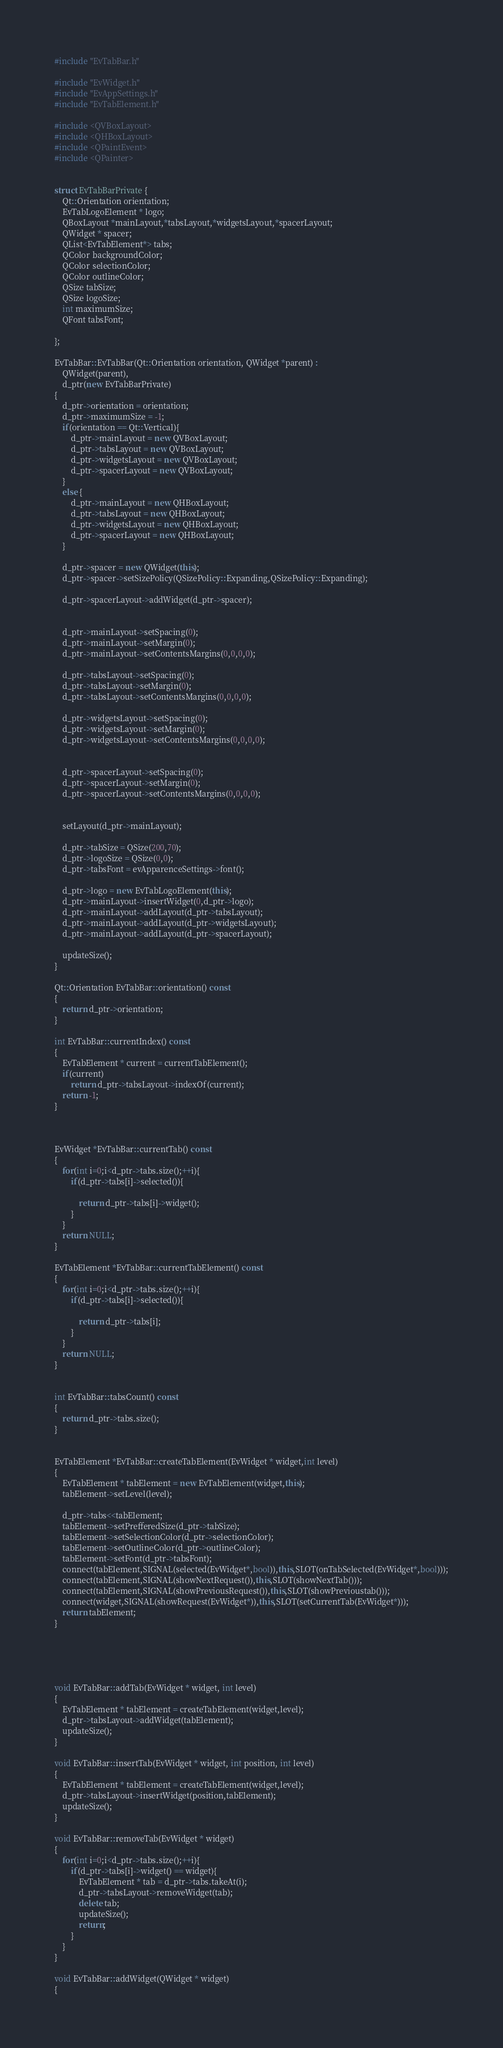Convert code to text. <code><loc_0><loc_0><loc_500><loc_500><_C++_>#include "EvTabBar.h"

#include "EvWidget.h"
#include "EvAppSettings.h"
#include "EvTabElement.h"

#include <QVBoxLayout>
#include <QHBoxLayout>
#include <QPaintEvent>
#include <QPainter>


struct EvTabBarPrivate {
    Qt::Orientation orientation;
    EvTabLogoElement * logo;
    QBoxLayout *mainLayout,*tabsLayout,*widgetsLayout,*spacerLayout;
    QWidget * spacer;
    QList<EvTabElement*> tabs;
    QColor backgroundColor;
    QColor selectionColor;
    QColor outlineColor;
    QSize tabSize;
    QSize logoSize;
    int maximumSize;
    QFont tabsFont;

};

EvTabBar::EvTabBar(Qt::Orientation orientation, QWidget *parent) :
    QWidget(parent),
    d_ptr(new EvTabBarPrivate)
{
    d_ptr->orientation = orientation;
    d_ptr->maximumSize = -1;
    if(orientation == Qt::Vertical){
        d_ptr->mainLayout = new QVBoxLayout;
        d_ptr->tabsLayout = new QVBoxLayout;
        d_ptr->widgetsLayout = new QVBoxLayout;
        d_ptr->spacerLayout = new QVBoxLayout;
    }
    else {
        d_ptr->mainLayout = new QHBoxLayout;
        d_ptr->tabsLayout = new QHBoxLayout;
        d_ptr->widgetsLayout = new QHBoxLayout;
        d_ptr->spacerLayout = new QHBoxLayout;
    }

    d_ptr->spacer = new QWidget(this);
    d_ptr->spacer->setSizePolicy(QSizePolicy::Expanding,QSizePolicy::Expanding);

    d_ptr->spacerLayout->addWidget(d_ptr->spacer);


    d_ptr->mainLayout->setSpacing(0);
    d_ptr->mainLayout->setMargin(0);
    d_ptr->mainLayout->setContentsMargins(0,0,0,0);

    d_ptr->tabsLayout->setSpacing(0);
    d_ptr->tabsLayout->setMargin(0);
    d_ptr->tabsLayout->setContentsMargins(0,0,0,0);

    d_ptr->widgetsLayout->setSpacing(0);
    d_ptr->widgetsLayout->setMargin(0);
    d_ptr->widgetsLayout->setContentsMargins(0,0,0,0);


    d_ptr->spacerLayout->setSpacing(0);
    d_ptr->spacerLayout->setMargin(0);
    d_ptr->spacerLayout->setContentsMargins(0,0,0,0);


    setLayout(d_ptr->mainLayout);

    d_ptr->tabSize = QSize(200,70);
    d_ptr->logoSize = QSize(0,0);
    d_ptr->tabsFont = evApparenceSettings->font();

    d_ptr->logo = new EvTabLogoElement(this);
    d_ptr->mainLayout->insertWidget(0,d_ptr->logo);
    d_ptr->mainLayout->addLayout(d_ptr->tabsLayout);
    d_ptr->mainLayout->addLayout(d_ptr->widgetsLayout);
    d_ptr->mainLayout->addLayout(d_ptr->spacerLayout);

    updateSize();
}

Qt::Orientation EvTabBar::orientation() const
{
    return d_ptr->orientation;
}

int EvTabBar::currentIndex() const
{
    EvTabElement * current = currentTabElement();
    if(current)
        return d_ptr->tabsLayout->indexOf(current);
    return -1;
}



EvWidget *EvTabBar::currentTab() const
{
    for(int i=0;i<d_ptr->tabs.size();++i){
        if(d_ptr->tabs[i]->selected()){

            return d_ptr->tabs[i]->widget();
        }
    }
    return NULL;
}

EvTabElement *EvTabBar::currentTabElement() const
{
    for(int i=0;i<d_ptr->tabs.size();++i){
        if(d_ptr->tabs[i]->selected()){

            return d_ptr->tabs[i];
        }
    }
    return NULL;
}


int EvTabBar::tabsCount() const
{
    return d_ptr->tabs.size();
}


EvTabElement *EvTabBar::createTabElement(EvWidget * widget,int level)
{
    EvTabElement * tabElement = new EvTabElement(widget,this);
    tabElement->setLevel(level);

    d_ptr->tabs<<tabElement;
    tabElement->setPrefferedSize(d_ptr->tabSize);
    tabElement->setSelectionColor(d_ptr->selectionColor);
    tabElement->setOutlineColor(d_ptr->outlineColor);
    tabElement->setFont(d_ptr->tabsFont);
    connect(tabElement,SIGNAL(selected(EvWidget*,bool)),this,SLOT(onTabSelected(EvWidget*,bool)));
    connect(tabElement,SIGNAL(showNextRequest()),this,SLOT(showNextTab()));
    connect(tabElement,SIGNAL(showPreviousRequest()),this,SLOT(showPrevioustab()));
    connect(widget,SIGNAL(showRequest(EvWidget*)),this,SLOT(setCurrentTab(EvWidget*)));
    return tabElement;
}





void EvTabBar::addTab(EvWidget * widget, int level)
{
    EvTabElement * tabElement = createTabElement(widget,level);
    d_ptr->tabsLayout->addWidget(tabElement);
    updateSize();
}

void EvTabBar::insertTab(EvWidget * widget, int position, int level)
{
    EvTabElement * tabElement = createTabElement(widget,level);
    d_ptr->tabsLayout->insertWidget(position,tabElement);
    updateSize();
}

void EvTabBar::removeTab(EvWidget * widget)
{
    for(int i=0;i<d_ptr->tabs.size();++i){
        if(d_ptr->tabs[i]->widget() == widget){
            EvTabElement * tab = d_ptr->tabs.takeAt(i);
            d_ptr->tabsLayout->removeWidget(tab);
            delete tab;
            updateSize();
            return;
        }
    }
}

void EvTabBar::addWidget(QWidget * widget)
{</code> 